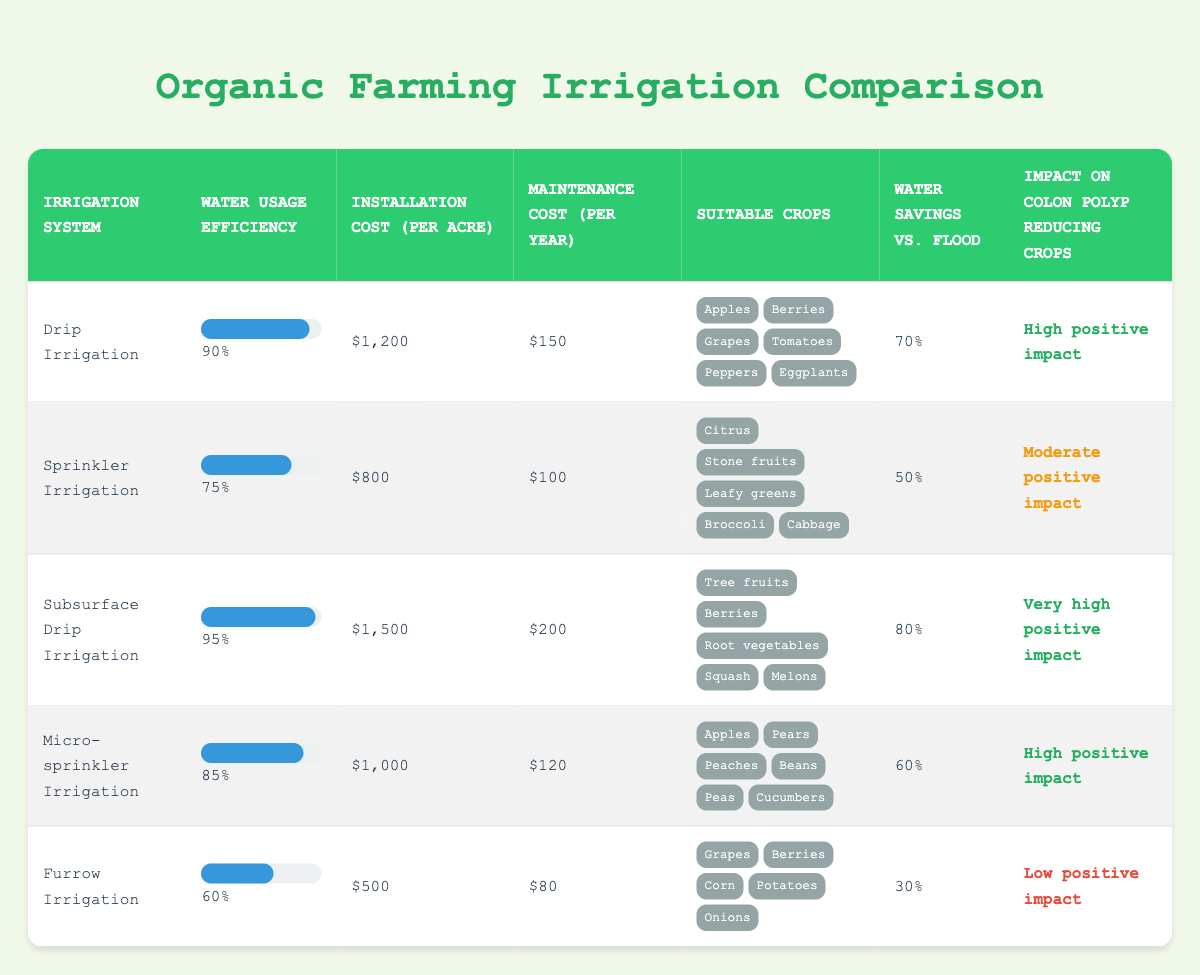What is the water usage efficiency of Subsurface Drip Irrigation? The table shows that Subsurface Drip Irrigation has a water usage efficiency of 95%.
Answer: 95% Which irrigation system has the highest installation cost per acre? By comparing the installation costs, Subsurface Drip Irrigation, with an installation cost of $1,500 per acre, has the highest cost.
Answer: Subsurface Drip Irrigation How much water savings does Drip Irrigation provide compared to Flood Irrigation? The table indicates that Drip Irrigation offers 70% water savings compared to Flood Irrigation.
Answer: 70% Is the Micro-sprinkler Irrigation suitable for root vegetables? The suitable crops for Micro-sprinkler Irrigation do not include root vegetables based on the table data, so the answer is no.
Answer: No What is the average water usage efficiency of all irrigation systems listed in the table? The water usage efficiencies are: 90, 75, 95, 85, and 60. The sum is 90 + 75 + 95 + 85 + 60 = 405, and there are 5 systems, so the average is 405/5 = 81.
Answer: 81 Which irrigation systems have a high positive impact on colon polyp reducing crops? The systems with a high positive impact are Drip Irrigation and Micro-sprinkler Irrigation, as marked in the table.
Answer: Drip Irrigation and Micro-sprinkler Irrigation What is the difference in installation cost between Furrow Irrigation and Sprinkler Irrigation? The installation cost of Furrow Irrigation is $500, and the cost of Sprinkler Irrigation is $800. The difference is $800 - $500 = $300.
Answer: 300 Which irrigation system provides the lowest water savings compared to flood? The table shows that Furrow Irrigation provides the lowest water savings at 30% compared to Flood Irrigation.
Answer: Furrow Irrigation Is there an irrigation system that has both high water usage efficiency and low maintenance cost? Comparing the systems, Drip Irrigation has high efficiency (90%) and a relatively low maintenance cost ($150), suggesting it fits these criteria.
Answer: Yes 